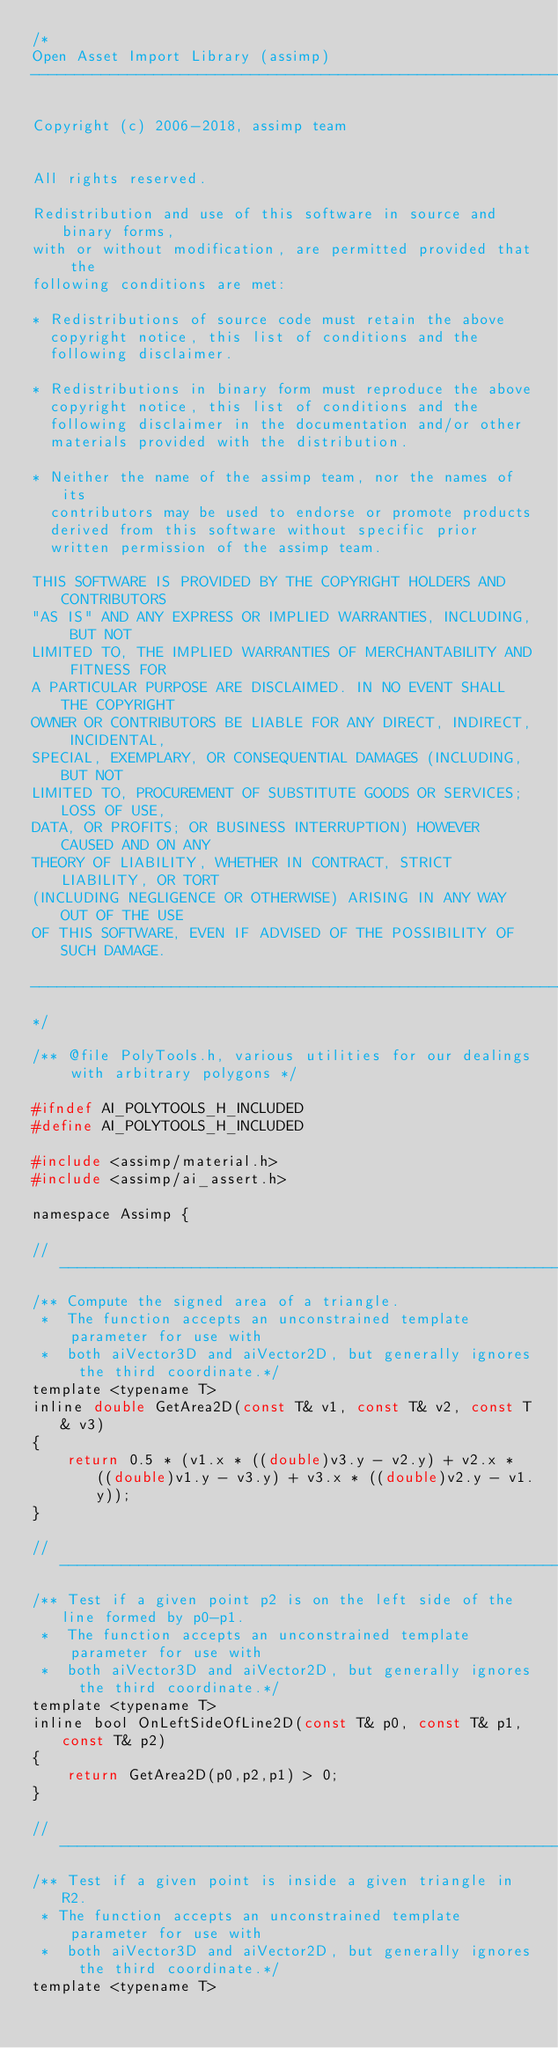<code> <loc_0><loc_0><loc_500><loc_500><_C_>/*
Open Asset Import Library (assimp)
----------------------------------------------------------------------

Copyright (c) 2006-2018, assimp team


All rights reserved.

Redistribution and use of this software in source and binary forms,
with or without modification, are permitted provided that the
following conditions are met:

* Redistributions of source code must retain the above
  copyright notice, this list of conditions and the
  following disclaimer.

* Redistributions in binary form must reproduce the above
  copyright notice, this list of conditions and the
  following disclaimer in the documentation and/or other
  materials provided with the distribution.

* Neither the name of the assimp team, nor the names of its
  contributors may be used to endorse or promote products
  derived from this software without specific prior
  written permission of the assimp team.

THIS SOFTWARE IS PROVIDED BY THE COPYRIGHT HOLDERS AND CONTRIBUTORS
"AS IS" AND ANY EXPRESS OR IMPLIED WARRANTIES, INCLUDING, BUT NOT
LIMITED TO, THE IMPLIED WARRANTIES OF MERCHANTABILITY AND FITNESS FOR
A PARTICULAR PURPOSE ARE DISCLAIMED. IN NO EVENT SHALL THE COPYRIGHT
OWNER OR CONTRIBUTORS BE LIABLE FOR ANY DIRECT, INDIRECT, INCIDENTAL,
SPECIAL, EXEMPLARY, OR CONSEQUENTIAL DAMAGES (INCLUDING, BUT NOT
LIMITED TO, PROCUREMENT OF SUBSTITUTE GOODS OR SERVICES; LOSS OF USE,
DATA, OR PROFITS; OR BUSINESS INTERRUPTION) HOWEVER CAUSED AND ON ANY
THEORY OF LIABILITY, WHETHER IN CONTRACT, STRICT LIABILITY, OR TORT
(INCLUDING NEGLIGENCE OR OTHERWISE) ARISING IN ANY WAY OUT OF THE USE
OF THIS SOFTWARE, EVEN IF ADVISED OF THE POSSIBILITY OF SUCH DAMAGE.

----------------------------------------------------------------------
*/

/** @file PolyTools.h, various utilities for our dealings with arbitrary polygons */

#ifndef AI_POLYTOOLS_H_INCLUDED
#define AI_POLYTOOLS_H_INCLUDED

#include <assimp/material.h>
#include <assimp/ai_assert.h>

namespace Assimp {

// -------------------------------------------------------------------------------
/** Compute the signed area of a triangle.
 *  The function accepts an unconstrained template parameter for use with
 *  both aiVector3D and aiVector2D, but generally ignores the third coordinate.*/
template <typename T>
inline double GetArea2D(const T& v1, const T& v2, const T& v3)
{
    return 0.5 * (v1.x * ((double)v3.y - v2.y) + v2.x * ((double)v1.y - v3.y) + v3.x * ((double)v2.y - v1.y));
}

// -------------------------------------------------------------------------------
/** Test if a given point p2 is on the left side of the line formed by p0-p1.
 *  The function accepts an unconstrained template parameter for use with
 *  both aiVector3D and aiVector2D, but generally ignores the third coordinate.*/
template <typename T>
inline bool OnLeftSideOfLine2D(const T& p0, const T& p1,const T& p2)
{
    return GetArea2D(p0,p2,p1) > 0;
}

// -------------------------------------------------------------------------------
/** Test if a given point is inside a given triangle in R2.
 * The function accepts an unconstrained template parameter for use with
 *  both aiVector3D and aiVector2D, but generally ignores the third coordinate.*/
template <typename T></code> 